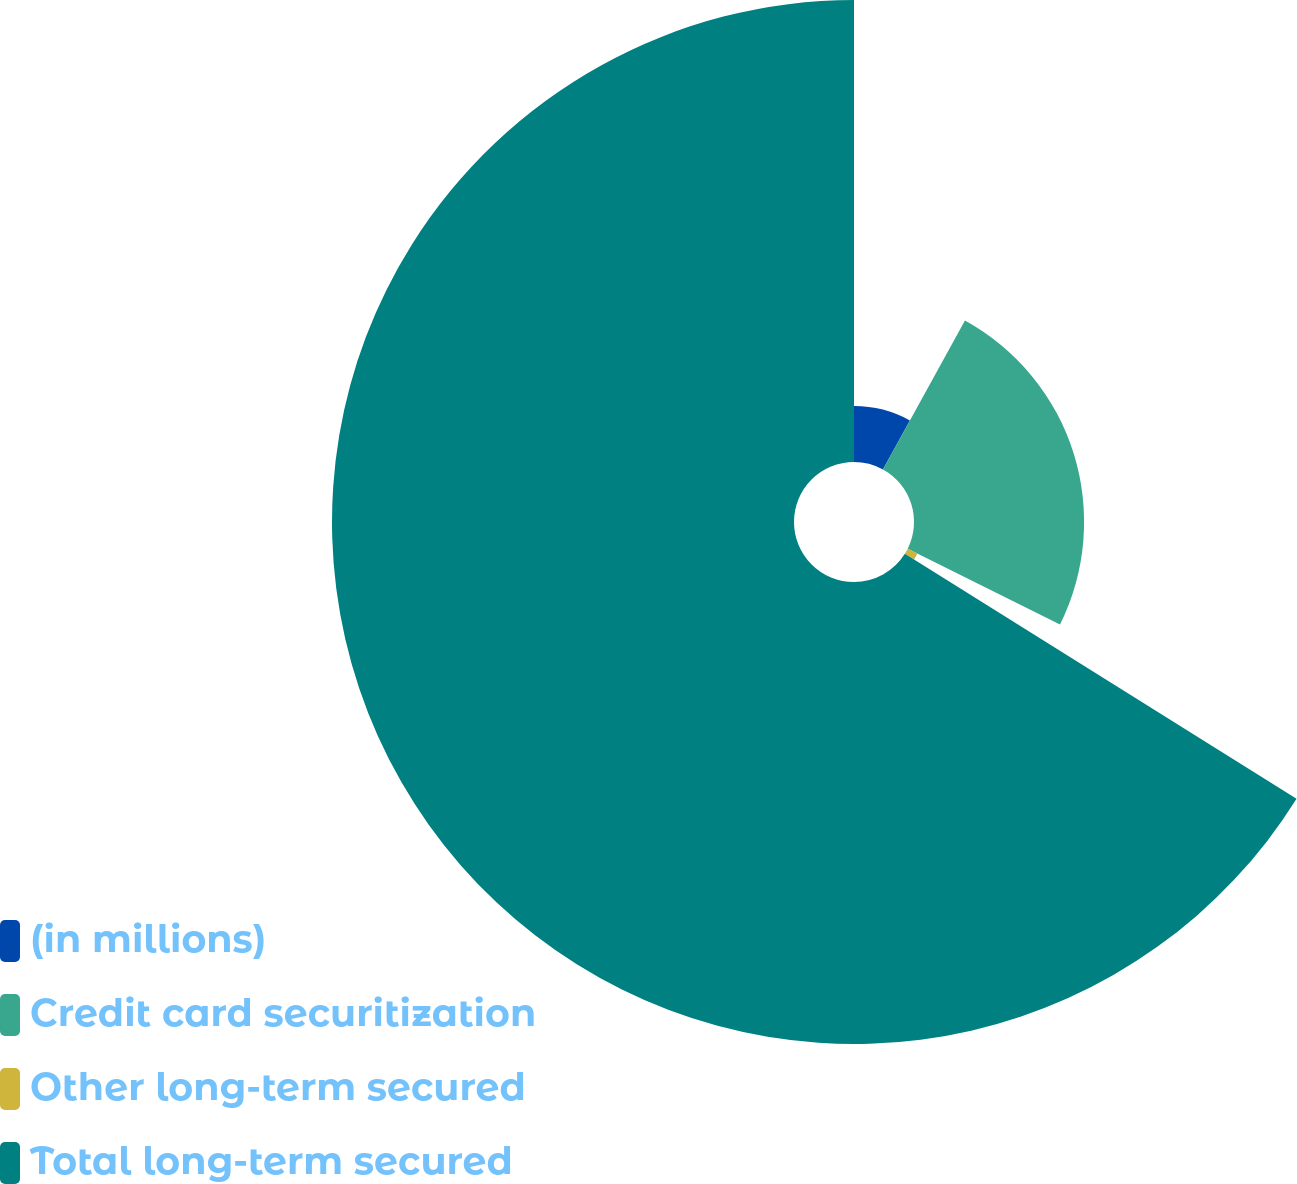<chart> <loc_0><loc_0><loc_500><loc_500><pie_chart><fcel>(in millions)<fcel>Credit card securitization<fcel>Other long-term secured<fcel>Total long-term secured<nl><fcel>8.01%<fcel>24.34%<fcel>1.55%<fcel>66.11%<nl></chart> 